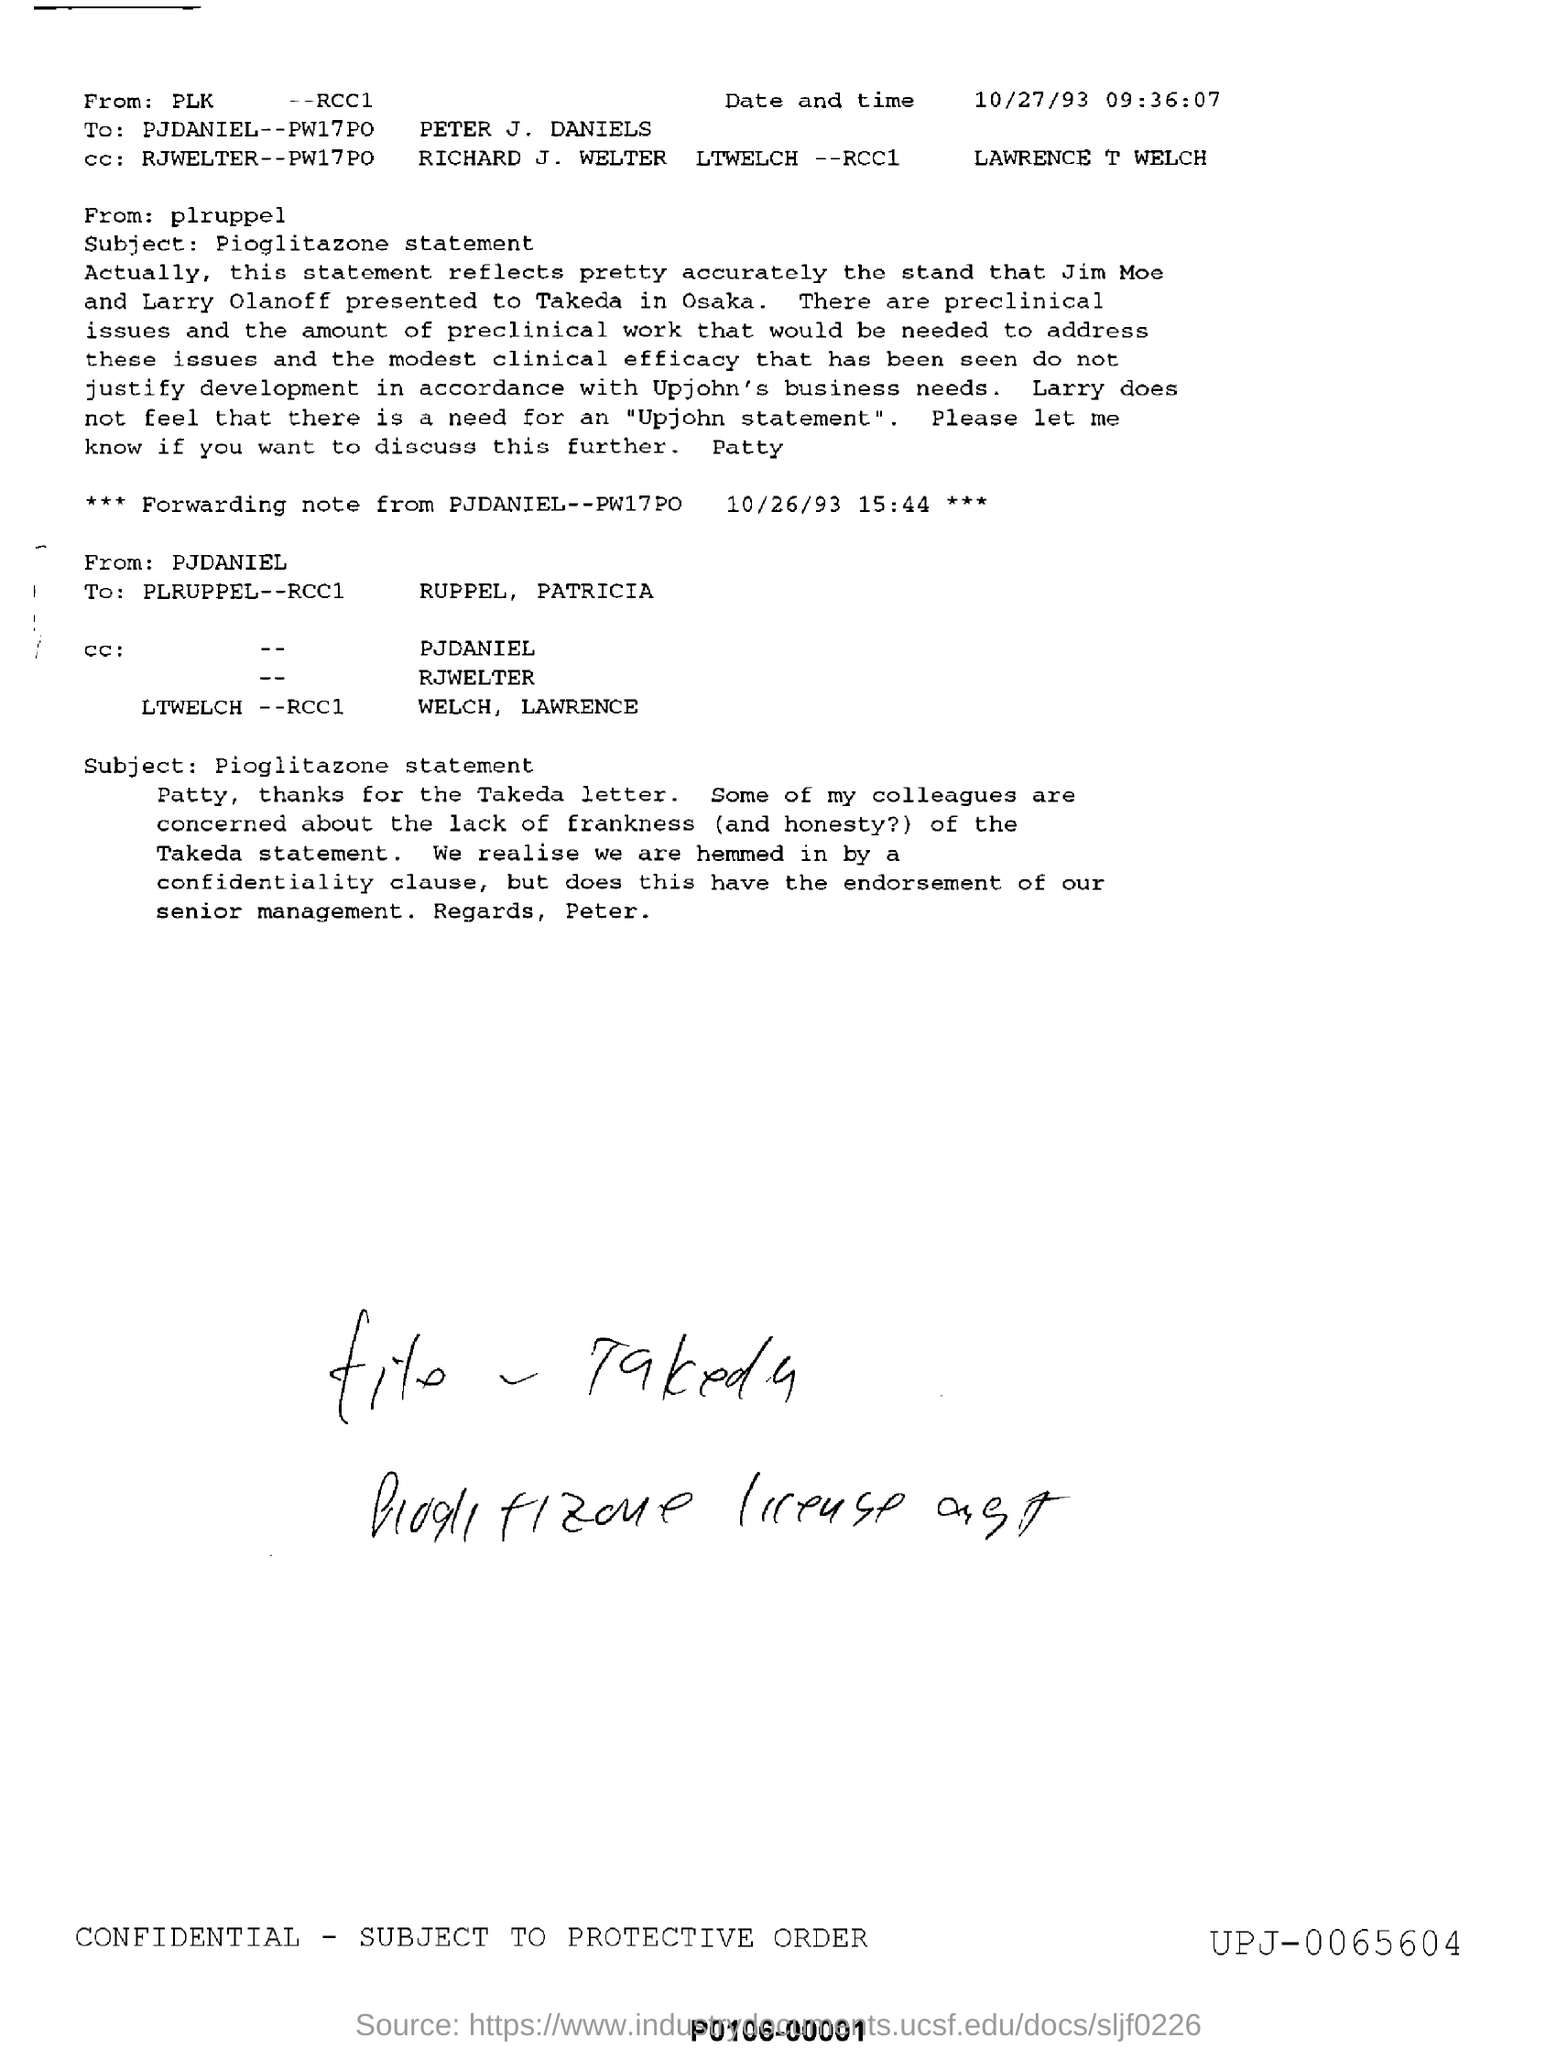What is the date and time mentioned ?
Provide a succinct answer. 10/27/93 09:36:07. What is mentioned in the subject ?
Offer a terse response. Pioglitazone statement. To whom this email was send?
Offer a terse response. PETER J. DANIELS. What is the date mentioned in the forwarding note ?
Offer a terse response. 10/26/93 15:44. What is the time mentioned in the forwarding note ?
Give a very brief answer. 15:44. To whom this email was forwaded?
Give a very brief answer. PLRUPPEL--RCC1 RUPPEL, PATRICIA. 